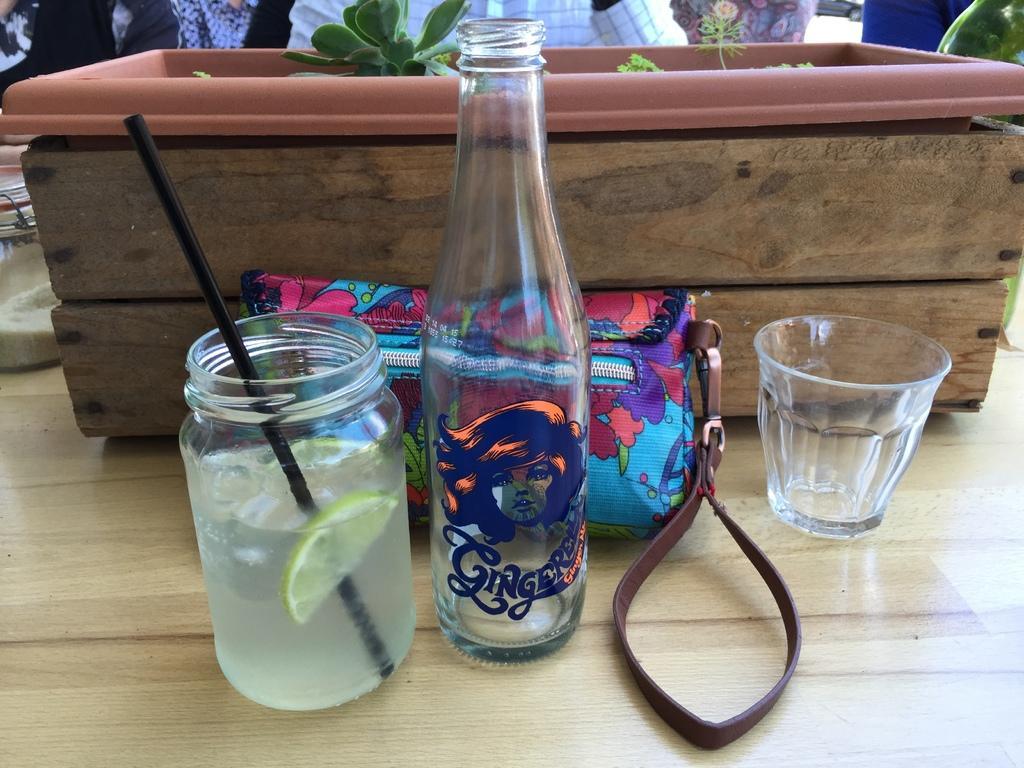Could you give a brief overview of what you see in this image? At the front side of image there is a bottle and a jar having some drink with lemon slice and straw in it and glass. Back to it there is a blue colour bag. There is a pot having some plants in it. At the top of the image there are few persons visible. 